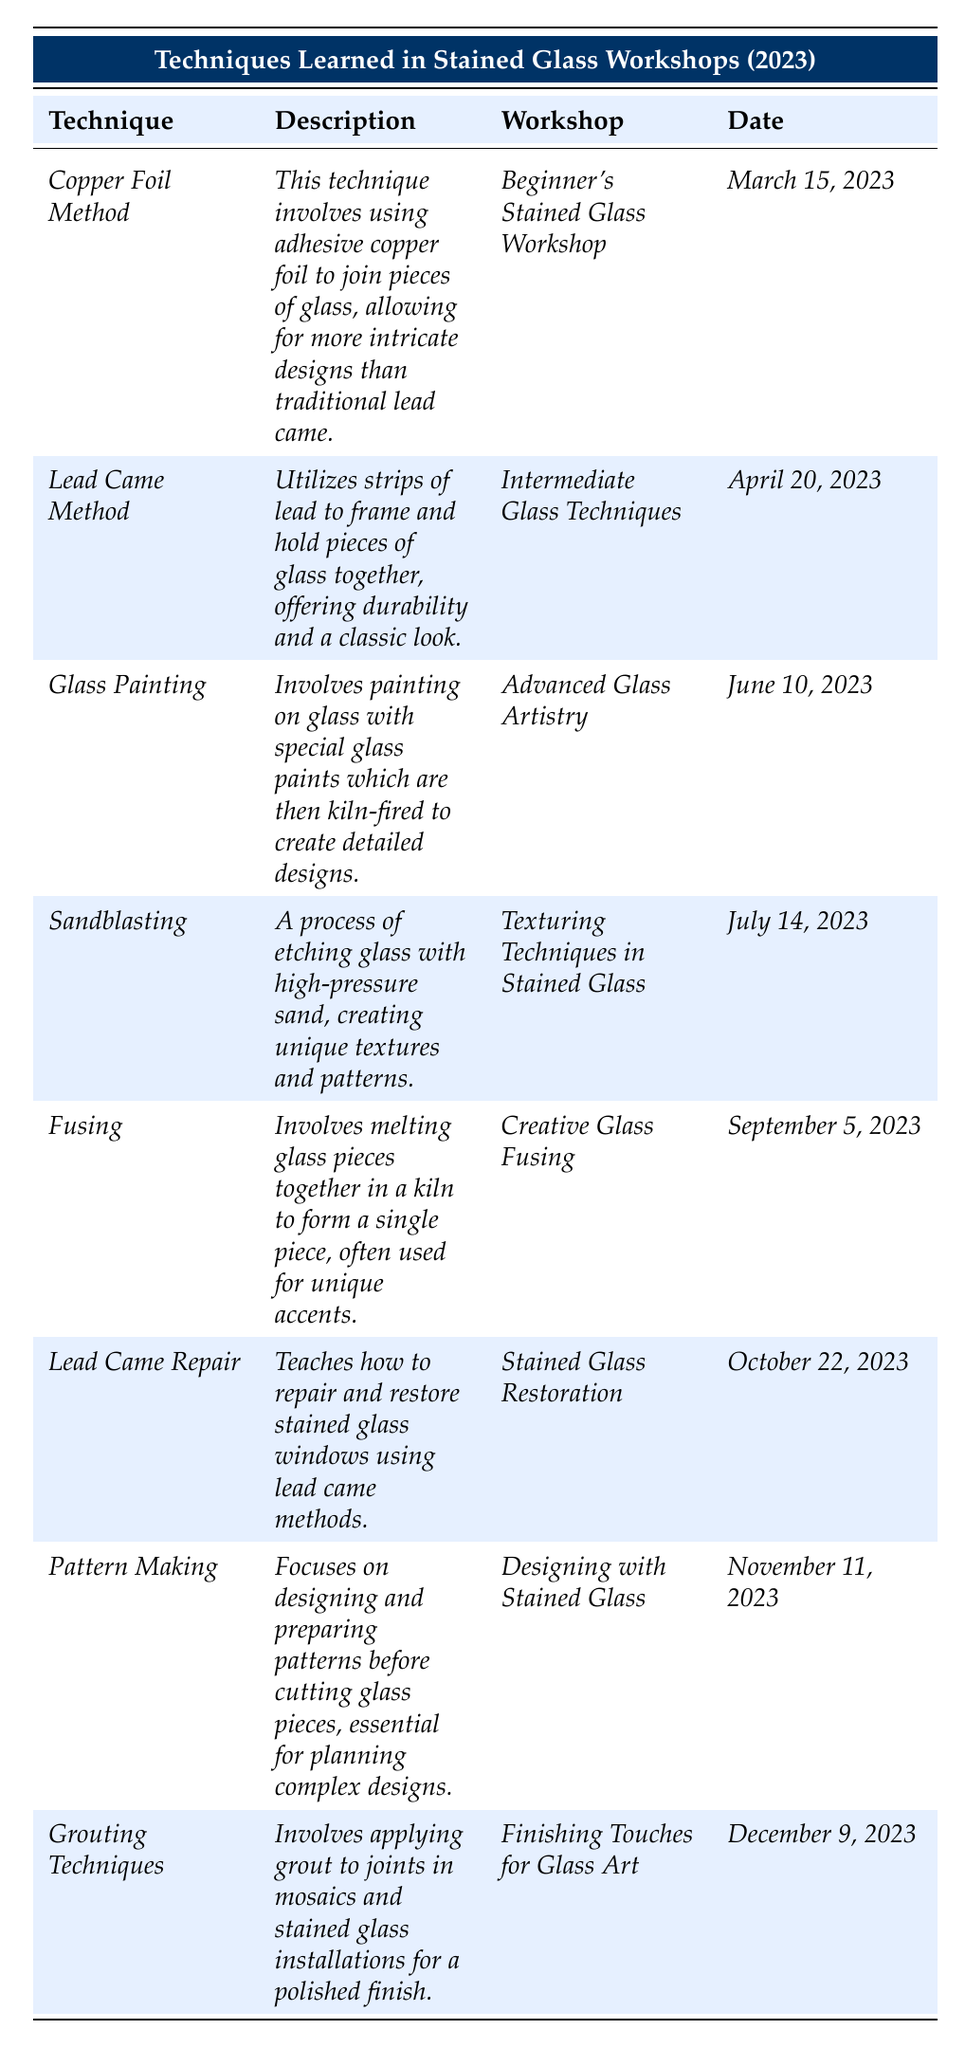What technique was taught in the workshop on March 15, 2023? The date March 15, 2023, corresponds to the workshop titled "Beginner's Stained Glass Workshop," which teaches the "Copper Foil Method."
Answer: Copper Foil Method Which workshop taught the technique of Glass Painting? The technique of Glass Painting is taught in the "Advanced Glass Artistry" workshop, as stated in the table.
Answer: Advanced Glass Artistry How many workshops were conducted before September 5, 2023? The workshops that occurred before September 5, 2023, are "Beginner's Stained Glass Workshop," "Intermediate Glass Techniques," "Advanced Glass Artistry," and "Texturing Techniques in Stained Glass," totaling four workshops.
Answer: 4 Is the Lead Came Repair technique associated with a workshop? Yes, the Lead Came Repair technique is associated with the "Stained Glass Restoration" workshop, as indicated in the table.
Answer: Yes What is the difference between the number of workshops that focus on techniques involving glass melting and those that utilize lead? There is one workshop focusing on glass melting, which is "Creative Glass Fusing." There are two workshops that utilize lead, which are "Lead Came Method" and "Lead Came Repair." The difference is 2 - 1 = 1.
Answer: 1 In which month was the Grouting Techniques workshop held? The table indicates that the Grouting Techniques workshop took place in December, specifically on December 9, 2023.
Answer: December Which technique deals with the repair and restoration of stained glass? The technique that involves the repair and restoration of stained glass is "Lead Came Repair," as identified in the table.
Answer: Lead Came Repair What workshops were focused on textures and patterns? The workshops focused on textures include "Texturing Techniques in Stained Glass," which teaches Sandblasting, and "Creative Glass Fusing," which involves Fusing, while the "Finishing Touches for Glass Art" workshop deals with Grouting Techniques. Thus, Sandblasting and Grouting Techniques workshops focus on textures and patterns.
Answer: Sandblasting, Grouting Techniques Which techniques learned in workshops have descriptions related to intricate designs? Both the "Copper Foil Method" and "Glass Painting" have descriptions that refer to intricate designs; Copper Foil allows for intricate designs, while Glass Painting involves detailed designs.
Answer: Copper Foil Method, Glass Painting How many techniques were learned in the year 2023? There are eight different techniques listed in the table, each corresponding to a specific workshop throughout the year 2023.
Answer: 8 